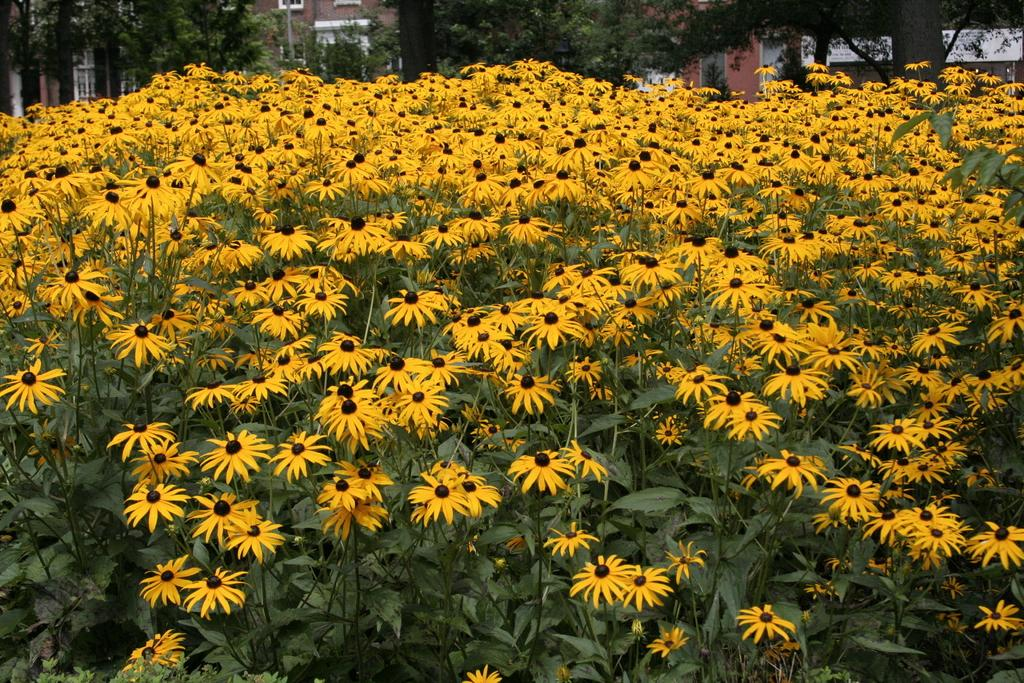What type of plants can be seen in the image? There are plants with flowers in the image. What can be seen in the background of the image? There are trees and buildings in the background of the image. Where is the minister standing in the image? There is no minister present in the image. What type of dock can be seen in the image? There is no dock present in the image. 